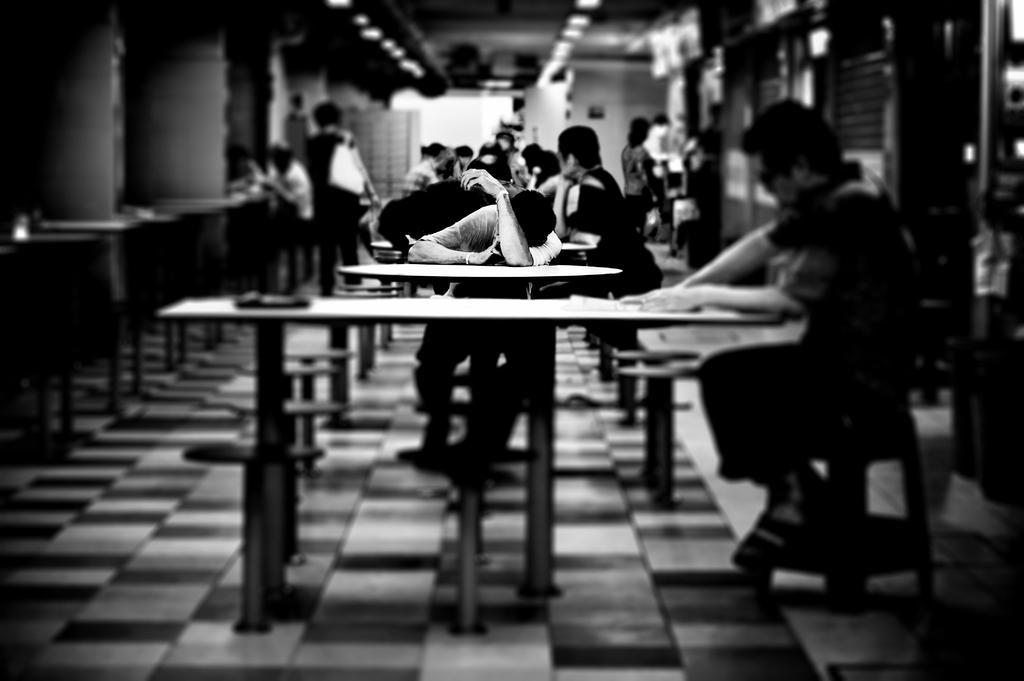How would you summarize this image in a sentence or two? As we can see in the image there is a wall, few people standing and sitting on chairs and there is a table over here. 